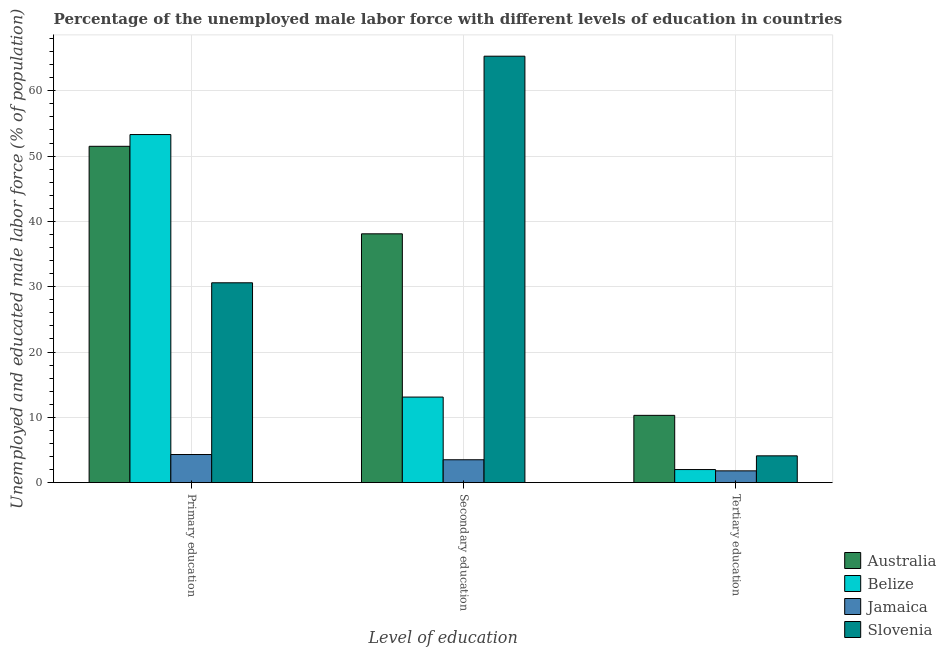Are the number of bars on each tick of the X-axis equal?
Give a very brief answer. Yes. What is the label of the 2nd group of bars from the left?
Ensure brevity in your answer.  Secondary education. Across all countries, what is the maximum percentage of male labor force who received primary education?
Give a very brief answer. 53.3. Across all countries, what is the minimum percentage of male labor force who received primary education?
Ensure brevity in your answer.  4.3. In which country was the percentage of male labor force who received secondary education maximum?
Your answer should be very brief. Slovenia. In which country was the percentage of male labor force who received primary education minimum?
Keep it short and to the point. Jamaica. What is the total percentage of male labor force who received secondary education in the graph?
Offer a terse response. 120. What is the difference between the percentage of male labor force who received tertiary education in Australia and that in Belize?
Make the answer very short. 8.3. What is the difference between the percentage of male labor force who received tertiary education in Australia and the percentage of male labor force who received secondary education in Slovenia?
Your answer should be compact. -55. What is the average percentage of male labor force who received tertiary education per country?
Offer a very short reply. 4.55. What is the difference between the percentage of male labor force who received tertiary education and percentage of male labor force who received primary education in Australia?
Give a very brief answer. -41.2. What is the ratio of the percentage of male labor force who received primary education in Slovenia to that in Jamaica?
Make the answer very short. 7.12. Is the difference between the percentage of male labor force who received secondary education in Jamaica and Belize greater than the difference between the percentage of male labor force who received tertiary education in Jamaica and Belize?
Provide a short and direct response. No. What is the difference between the highest and the second highest percentage of male labor force who received tertiary education?
Provide a short and direct response. 6.2. What is the difference between the highest and the lowest percentage of male labor force who received primary education?
Provide a short and direct response. 49. In how many countries, is the percentage of male labor force who received primary education greater than the average percentage of male labor force who received primary education taken over all countries?
Your response must be concise. 2. What does the 4th bar from the left in Secondary education represents?
Offer a very short reply. Slovenia. What does the 4th bar from the right in Tertiary education represents?
Make the answer very short. Australia. Is it the case that in every country, the sum of the percentage of male labor force who received primary education and percentage of male labor force who received secondary education is greater than the percentage of male labor force who received tertiary education?
Provide a succinct answer. Yes. How many bars are there?
Ensure brevity in your answer.  12. Are all the bars in the graph horizontal?
Your response must be concise. No. What is the title of the graph?
Your response must be concise. Percentage of the unemployed male labor force with different levels of education in countries. Does "Costa Rica" appear as one of the legend labels in the graph?
Offer a very short reply. No. What is the label or title of the X-axis?
Your answer should be very brief. Level of education. What is the label or title of the Y-axis?
Your response must be concise. Unemployed and educated male labor force (% of population). What is the Unemployed and educated male labor force (% of population) of Australia in Primary education?
Keep it short and to the point. 51.5. What is the Unemployed and educated male labor force (% of population) of Belize in Primary education?
Your answer should be compact. 53.3. What is the Unemployed and educated male labor force (% of population) in Jamaica in Primary education?
Provide a succinct answer. 4.3. What is the Unemployed and educated male labor force (% of population) in Slovenia in Primary education?
Give a very brief answer. 30.6. What is the Unemployed and educated male labor force (% of population) in Australia in Secondary education?
Your answer should be compact. 38.1. What is the Unemployed and educated male labor force (% of population) of Belize in Secondary education?
Ensure brevity in your answer.  13.1. What is the Unemployed and educated male labor force (% of population) of Jamaica in Secondary education?
Your response must be concise. 3.5. What is the Unemployed and educated male labor force (% of population) of Slovenia in Secondary education?
Your answer should be compact. 65.3. What is the Unemployed and educated male labor force (% of population) in Australia in Tertiary education?
Ensure brevity in your answer.  10.3. What is the Unemployed and educated male labor force (% of population) of Jamaica in Tertiary education?
Your answer should be very brief. 1.8. What is the Unemployed and educated male labor force (% of population) of Slovenia in Tertiary education?
Your answer should be compact. 4.1. Across all Level of education, what is the maximum Unemployed and educated male labor force (% of population) in Australia?
Offer a terse response. 51.5. Across all Level of education, what is the maximum Unemployed and educated male labor force (% of population) of Belize?
Keep it short and to the point. 53.3. Across all Level of education, what is the maximum Unemployed and educated male labor force (% of population) of Jamaica?
Provide a short and direct response. 4.3. Across all Level of education, what is the maximum Unemployed and educated male labor force (% of population) in Slovenia?
Keep it short and to the point. 65.3. Across all Level of education, what is the minimum Unemployed and educated male labor force (% of population) of Australia?
Offer a terse response. 10.3. Across all Level of education, what is the minimum Unemployed and educated male labor force (% of population) of Belize?
Your answer should be compact. 2. Across all Level of education, what is the minimum Unemployed and educated male labor force (% of population) of Jamaica?
Give a very brief answer. 1.8. Across all Level of education, what is the minimum Unemployed and educated male labor force (% of population) of Slovenia?
Provide a succinct answer. 4.1. What is the total Unemployed and educated male labor force (% of population) of Australia in the graph?
Make the answer very short. 99.9. What is the total Unemployed and educated male labor force (% of population) in Belize in the graph?
Offer a terse response. 68.4. What is the total Unemployed and educated male labor force (% of population) of Jamaica in the graph?
Your answer should be very brief. 9.6. What is the difference between the Unemployed and educated male labor force (% of population) of Belize in Primary education and that in Secondary education?
Provide a succinct answer. 40.2. What is the difference between the Unemployed and educated male labor force (% of population) in Slovenia in Primary education and that in Secondary education?
Ensure brevity in your answer.  -34.7. What is the difference between the Unemployed and educated male labor force (% of population) in Australia in Primary education and that in Tertiary education?
Your answer should be very brief. 41.2. What is the difference between the Unemployed and educated male labor force (% of population) of Belize in Primary education and that in Tertiary education?
Provide a short and direct response. 51.3. What is the difference between the Unemployed and educated male labor force (% of population) of Jamaica in Primary education and that in Tertiary education?
Your answer should be compact. 2.5. What is the difference between the Unemployed and educated male labor force (% of population) of Australia in Secondary education and that in Tertiary education?
Your answer should be very brief. 27.8. What is the difference between the Unemployed and educated male labor force (% of population) of Jamaica in Secondary education and that in Tertiary education?
Offer a terse response. 1.7. What is the difference between the Unemployed and educated male labor force (% of population) in Slovenia in Secondary education and that in Tertiary education?
Give a very brief answer. 61.2. What is the difference between the Unemployed and educated male labor force (% of population) in Australia in Primary education and the Unemployed and educated male labor force (% of population) in Belize in Secondary education?
Your response must be concise. 38.4. What is the difference between the Unemployed and educated male labor force (% of population) of Australia in Primary education and the Unemployed and educated male labor force (% of population) of Jamaica in Secondary education?
Ensure brevity in your answer.  48. What is the difference between the Unemployed and educated male labor force (% of population) in Australia in Primary education and the Unemployed and educated male labor force (% of population) in Slovenia in Secondary education?
Offer a terse response. -13.8. What is the difference between the Unemployed and educated male labor force (% of population) in Belize in Primary education and the Unemployed and educated male labor force (% of population) in Jamaica in Secondary education?
Keep it short and to the point. 49.8. What is the difference between the Unemployed and educated male labor force (% of population) of Jamaica in Primary education and the Unemployed and educated male labor force (% of population) of Slovenia in Secondary education?
Make the answer very short. -61. What is the difference between the Unemployed and educated male labor force (% of population) in Australia in Primary education and the Unemployed and educated male labor force (% of population) in Belize in Tertiary education?
Keep it short and to the point. 49.5. What is the difference between the Unemployed and educated male labor force (% of population) of Australia in Primary education and the Unemployed and educated male labor force (% of population) of Jamaica in Tertiary education?
Your response must be concise. 49.7. What is the difference between the Unemployed and educated male labor force (% of population) in Australia in Primary education and the Unemployed and educated male labor force (% of population) in Slovenia in Tertiary education?
Offer a terse response. 47.4. What is the difference between the Unemployed and educated male labor force (% of population) of Belize in Primary education and the Unemployed and educated male labor force (% of population) of Jamaica in Tertiary education?
Provide a short and direct response. 51.5. What is the difference between the Unemployed and educated male labor force (% of population) of Belize in Primary education and the Unemployed and educated male labor force (% of population) of Slovenia in Tertiary education?
Make the answer very short. 49.2. What is the difference between the Unemployed and educated male labor force (% of population) of Australia in Secondary education and the Unemployed and educated male labor force (% of population) of Belize in Tertiary education?
Provide a succinct answer. 36.1. What is the difference between the Unemployed and educated male labor force (% of population) in Australia in Secondary education and the Unemployed and educated male labor force (% of population) in Jamaica in Tertiary education?
Offer a terse response. 36.3. What is the difference between the Unemployed and educated male labor force (% of population) in Belize in Secondary education and the Unemployed and educated male labor force (% of population) in Jamaica in Tertiary education?
Your response must be concise. 11.3. What is the average Unemployed and educated male labor force (% of population) in Australia per Level of education?
Your answer should be very brief. 33.3. What is the average Unemployed and educated male labor force (% of population) in Belize per Level of education?
Give a very brief answer. 22.8. What is the average Unemployed and educated male labor force (% of population) of Jamaica per Level of education?
Offer a terse response. 3.2. What is the average Unemployed and educated male labor force (% of population) of Slovenia per Level of education?
Your answer should be very brief. 33.33. What is the difference between the Unemployed and educated male labor force (% of population) of Australia and Unemployed and educated male labor force (% of population) of Jamaica in Primary education?
Provide a short and direct response. 47.2. What is the difference between the Unemployed and educated male labor force (% of population) in Australia and Unemployed and educated male labor force (% of population) in Slovenia in Primary education?
Offer a very short reply. 20.9. What is the difference between the Unemployed and educated male labor force (% of population) in Belize and Unemployed and educated male labor force (% of population) in Slovenia in Primary education?
Ensure brevity in your answer.  22.7. What is the difference between the Unemployed and educated male labor force (% of population) of Jamaica and Unemployed and educated male labor force (% of population) of Slovenia in Primary education?
Ensure brevity in your answer.  -26.3. What is the difference between the Unemployed and educated male labor force (% of population) of Australia and Unemployed and educated male labor force (% of population) of Jamaica in Secondary education?
Provide a succinct answer. 34.6. What is the difference between the Unemployed and educated male labor force (% of population) in Australia and Unemployed and educated male labor force (% of population) in Slovenia in Secondary education?
Offer a terse response. -27.2. What is the difference between the Unemployed and educated male labor force (% of population) of Belize and Unemployed and educated male labor force (% of population) of Slovenia in Secondary education?
Keep it short and to the point. -52.2. What is the difference between the Unemployed and educated male labor force (% of population) in Jamaica and Unemployed and educated male labor force (% of population) in Slovenia in Secondary education?
Ensure brevity in your answer.  -61.8. What is the difference between the Unemployed and educated male labor force (% of population) of Australia and Unemployed and educated male labor force (% of population) of Jamaica in Tertiary education?
Give a very brief answer. 8.5. What is the difference between the Unemployed and educated male labor force (% of population) in Australia and Unemployed and educated male labor force (% of population) in Slovenia in Tertiary education?
Your answer should be compact. 6.2. What is the difference between the Unemployed and educated male labor force (% of population) of Belize and Unemployed and educated male labor force (% of population) of Jamaica in Tertiary education?
Offer a terse response. 0.2. What is the difference between the Unemployed and educated male labor force (% of population) of Belize and Unemployed and educated male labor force (% of population) of Slovenia in Tertiary education?
Offer a terse response. -2.1. What is the ratio of the Unemployed and educated male labor force (% of population) in Australia in Primary education to that in Secondary education?
Keep it short and to the point. 1.35. What is the ratio of the Unemployed and educated male labor force (% of population) in Belize in Primary education to that in Secondary education?
Offer a terse response. 4.07. What is the ratio of the Unemployed and educated male labor force (% of population) in Jamaica in Primary education to that in Secondary education?
Your answer should be very brief. 1.23. What is the ratio of the Unemployed and educated male labor force (% of population) in Slovenia in Primary education to that in Secondary education?
Offer a very short reply. 0.47. What is the ratio of the Unemployed and educated male labor force (% of population) in Australia in Primary education to that in Tertiary education?
Your response must be concise. 5. What is the ratio of the Unemployed and educated male labor force (% of population) of Belize in Primary education to that in Tertiary education?
Offer a terse response. 26.65. What is the ratio of the Unemployed and educated male labor force (% of population) in Jamaica in Primary education to that in Tertiary education?
Give a very brief answer. 2.39. What is the ratio of the Unemployed and educated male labor force (% of population) in Slovenia in Primary education to that in Tertiary education?
Make the answer very short. 7.46. What is the ratio of the Unemployed and educated male labor force (% of population) of Australia in Secondary education to that in Tertiary education?
Your answer should be compact. 3.7. What is the ratio of the Unemployed and educated male labor force (% of population) in Belize in Secondary education to that in Tertiary education?
Your answer should be compact. 6.55. What is the ratio of the Unemployed and educated male labor force (% of population) of Jamaica in Secondary education to that in Tertiary education?
Give a very brief answer. 1.94. What is the ratio of the Unemployed and educated male labor force (% of population) in Slovenia in Secondary education to that in Tertiary education?
Keep it short and to the point. 15.93. What is the difference between the highest and the second highest Unemployed and educated male labor force (% of population) of Belize?
Provide a short and direct response. 40.2. What is the difference between the highest and the second highest Unemployed and educated male labor force (% of population) in Jamaica?
Your answer should be very brief. 0.8. What is the difference between the highest and the second highest Unemployed and educated male labor force (% of population) in Slovenia?
Provide a short and direct response. 34.7. What is the difference between the highest and the lowest Unemployed and educated male labor force (% of population) in Australia?
Ensure brevity in your answer.  41.2. What is the difference between the highest and the lowest Unemployed and educated male labor force (% of population) of Belize?
Make the answer very short. 51.3. What is the difference between the highest and the lowest Unemployed and educated male labor force (% of population) in Jamaica?
Provide a succinct answer. 2.5. What is the difference between the highest and the lowest Unemployed and educated male labor force (% of population) of Slovenia?
Your answer should be very brief. 61.2. 